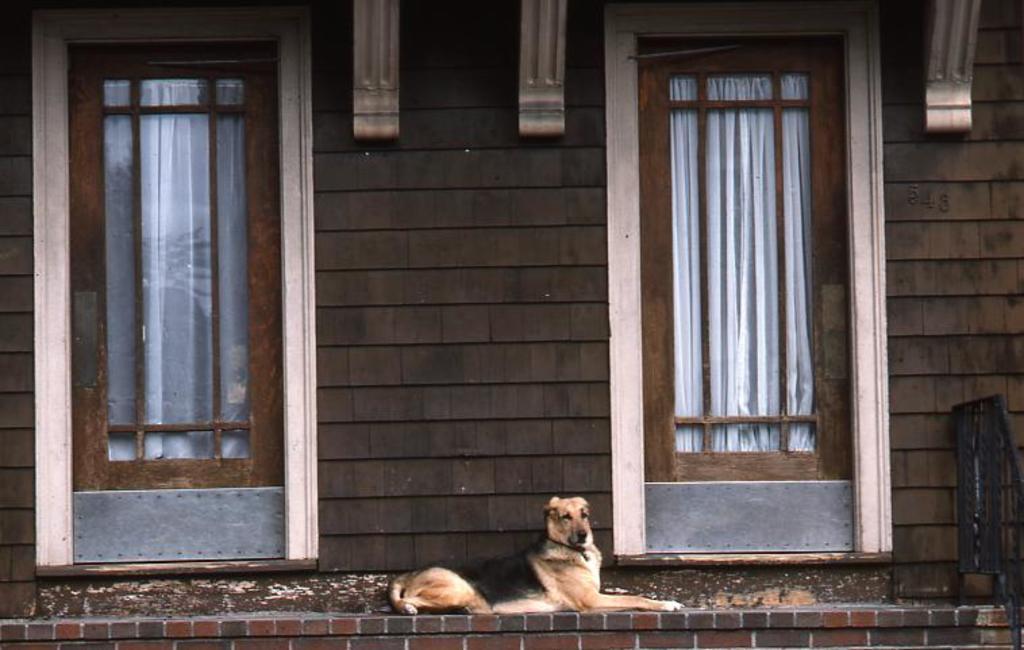Can you describe this image briefly? There is a dog sitting on the wall and there is a glass door on either sides of it. 